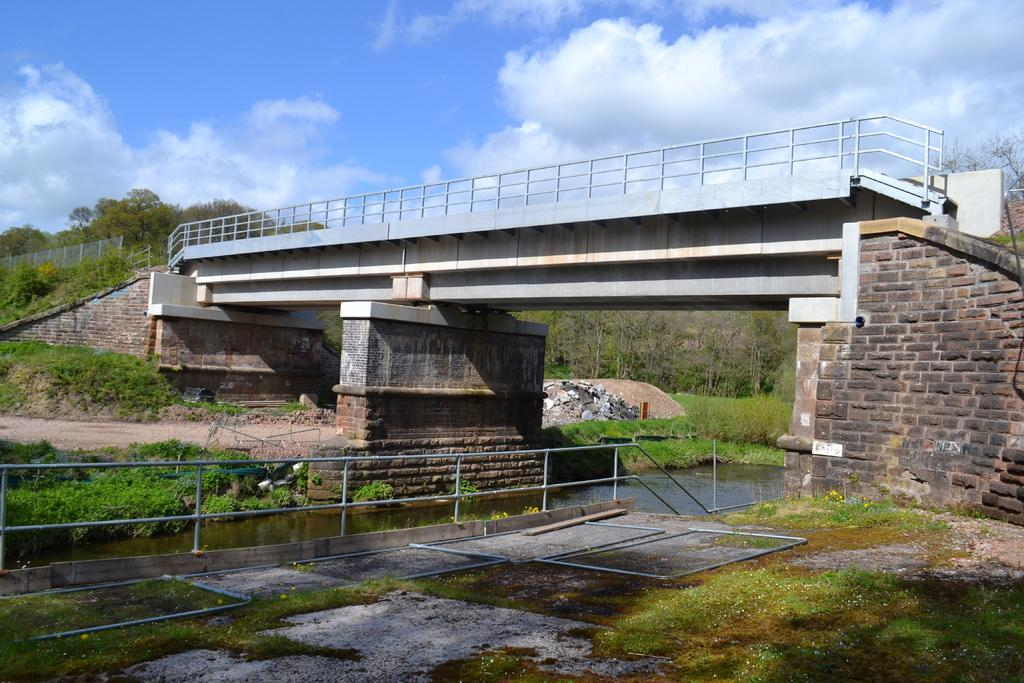What is located in the center of the image? There is water, grass, and a fence in the center of the image. What can be seen in the background of the image? The sky, clouds, trees, plants, grass, a fence, stones, and a bridge are present in the background of the image. Can you tell me how many toes are visible on the hydrant in the image? There is no hydrant present in the image, so it is not possible to determine how many toes might be visible on it. What type of authority is depicted in the image? There is no depiction of authority in the image; it features water, grass, a fence, and various elements in the background. 